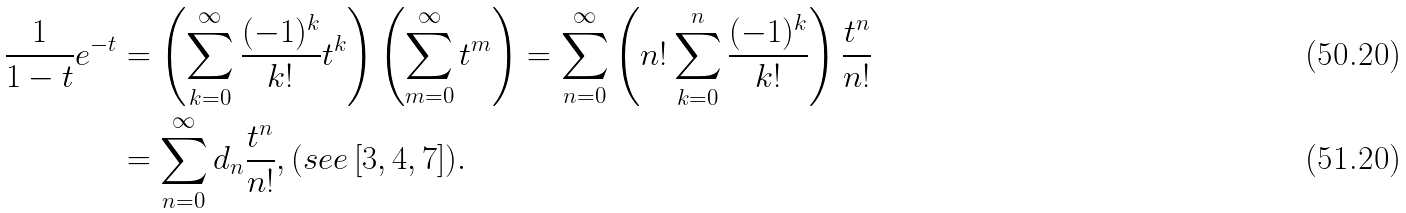<formula> <loc_0><loc_0><loc_500><loc_500>\frac { 1 } { 1 - t } e ^ { - t } & = \left ( \sum _ { k = 0 } ^ { \infty } \frac { ( - 1 ) ^ { k } } { k ! } t ^ { k } \right ) \left ( \sum _ { m = 0 } ^ { \infty } t ^ { m } \right ) = \sum _ { n = 0 } ^ { \infty } \left ( n ! \sum _ { k = 0 } ^ { n } \frac { ( - 1 ) ^ { k } } { k ! } \right ) \frac { t ^ { n } } { n ! } \\ & = \sum _ { n = 0 } ^ { \infty } d _ { n } \frac { t ^ { n } } { n ! } , ( s e e \, [ 3 , 4 , 7 ] ) .</formula> 